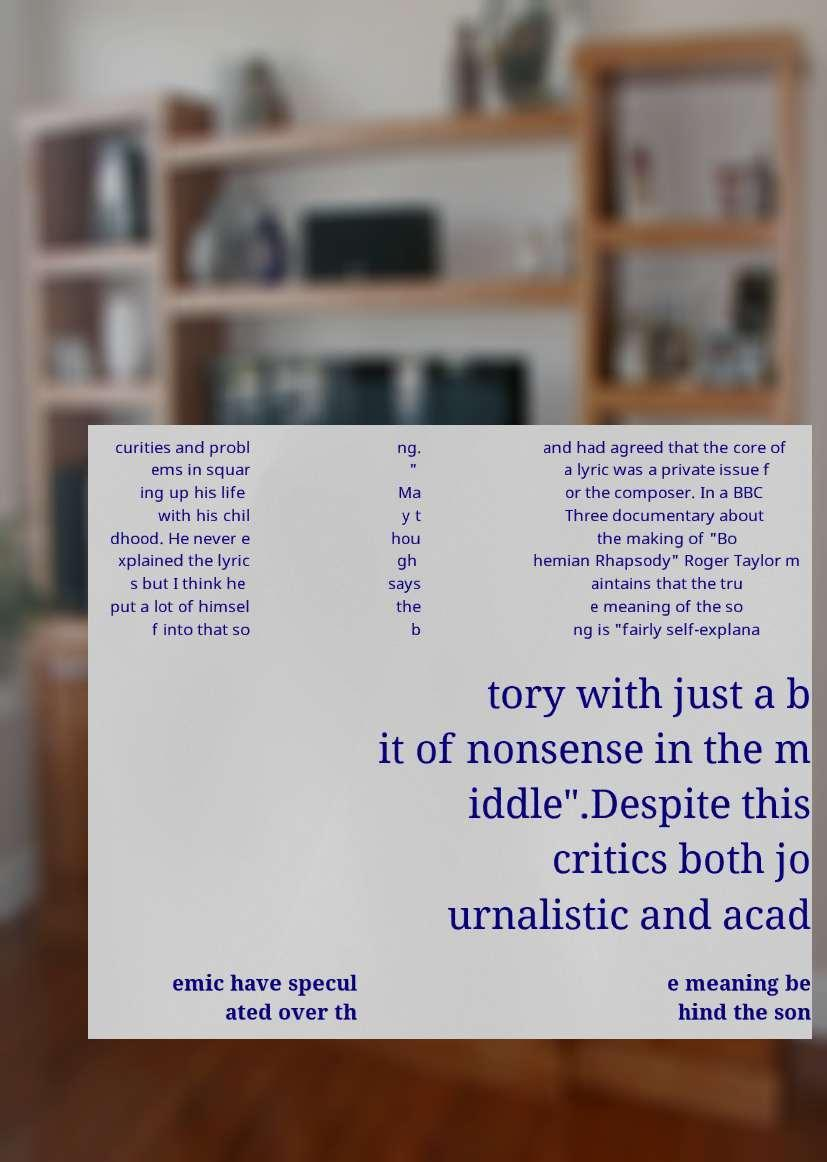Can you accurately transcribe the text from the provided image for me? curities and probl ems in squar ing up his life with his chil dhood. He never e xplained the lyric s but I think he put a lot of himsel f into that so ng. " Ma y t hou gh says the b and had agreed that the core of a lyric was a private issue f or the composer. In a BBC Three documentary about the making of "Bo hemian Rhapsody" Roger Taylor m aintains that the tru e meaning of the so ng is "fairly self-explana tory with just a b it of nonsense in the m iddle".Despite this critics both jo urnalistic and acad emic have specul ated over th e meaning be hind the son 